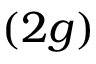<formula> <loc_0><loc_0><loc_500><loc_500>( 2 g )</formula> 